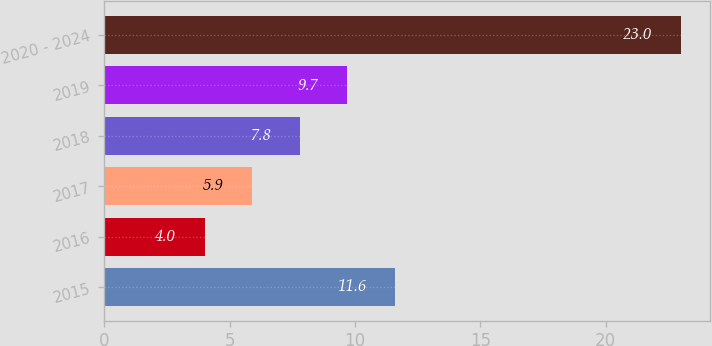Convert chart. <chart><loc_0><loc_0><loc_500><loc_500><bar_chart><fcel>2015<fcel>2016<fcel>2017<fcel>2018<fcel>2019<fcel>2020 - 2024<nl><fcel>11.6<fcel>4<fcel>5.9<fcel>7.8<fcel>9.7<fcel>23<nl></chart> 